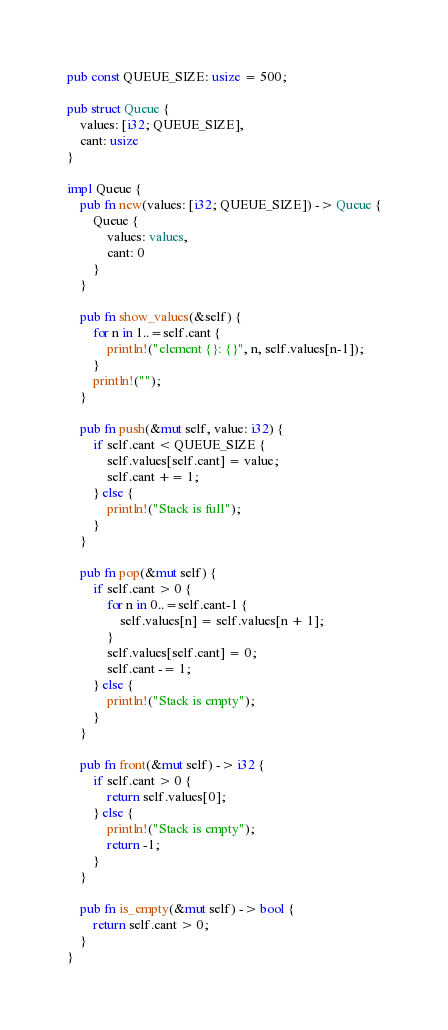<code> <loc_0><loc_0><loc_500><loc_500><_Rust_>pub const QUEUE_SIZE: usize = 500;

pub struct Queue {
    values: [i32; QUEUE_SIZE],
    cant: usize
}

impl Queue {
    pub fn new(values: [i32; QUEUE_SIZE]) -> Queue {
        Queue {
            values: values,
            cant: 0
        }
    }

    pub fn show_values(&self) {
        for n in 1..=self.cant {
            println!("element {}: {}", n, self.values[n-1]);
        }
        println!("");
    }

    pub fn push(&mut self, value: i32) {
        if self.cant < QUEUE_SIZE {
            self.values[self.cant] = value;
            self.cant += 1;
        } else {
            println!("Stack is full");
        }
    }

    pub fn pop(&mut self) {
        if self.cant > 0 {
            for n in 0..=self.cant-1 {
                self.values[n] = self.values[n + 1];
            }
            self.values[self.cant] = 0;
            self.cant -= 1;
        } else {
            println!("Stack is empty");
        }
    }

    pub fn front(&mut self) -> i32 {
        if self.cant > 0 {
            return self.values[0];
        } else {
            println!("Stack is empty");
            return -1;
        }
    }

    pub fn is_empty(&mut self) -> bool {
        return self.cant > 0;
    }
}</code> 